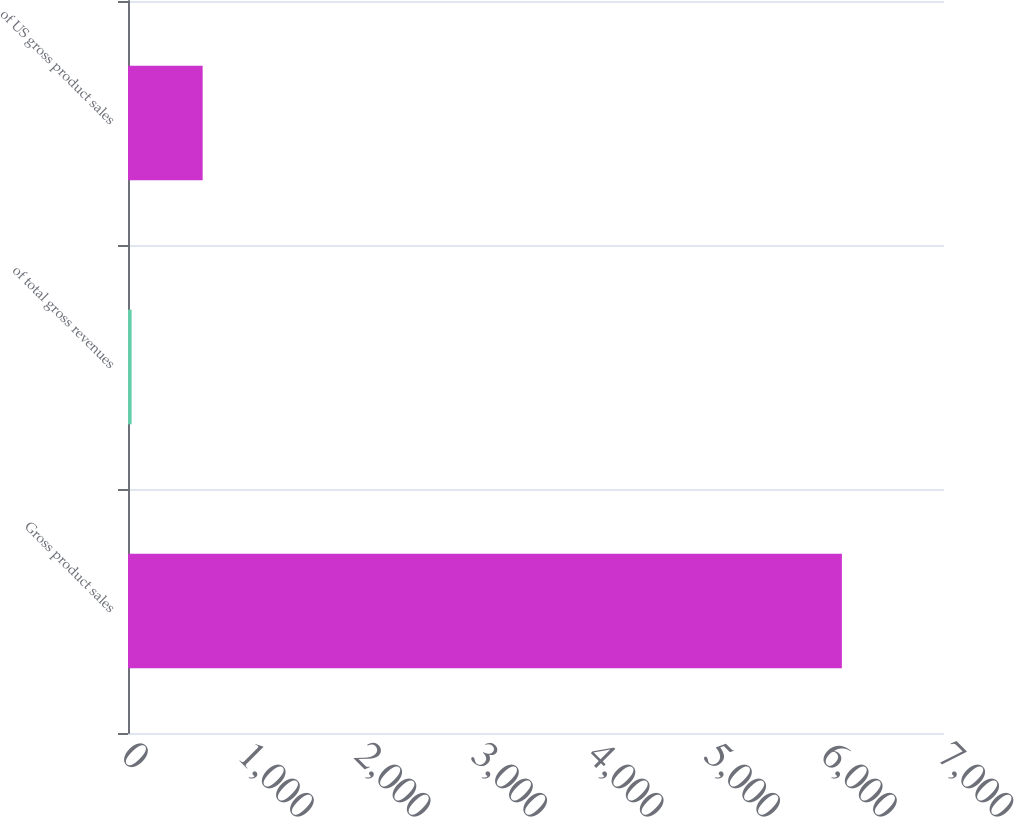Convert chart. <chart><loc_0><loc_0><loc_500><loc_500><bar_chart><fcel>Gross product sales<fcel>of total gross revenues<fcel>of US gross product sales<nl><fcel>6124<fcel>31<fcel>640.3<nl></chart> 